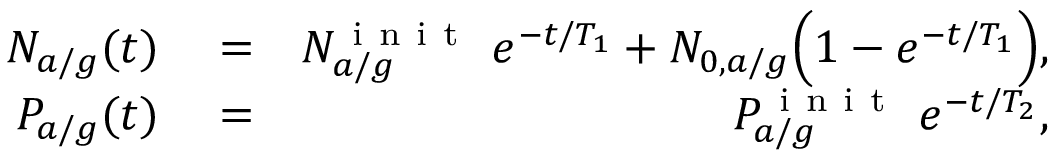Convert formula to latex. <formula><loc_0><loc_0><loc_500><loc_500>\begin{array} { r l r } { N _ { a / g } ( t ) } & = } & { N _ { a / g } ^ { i n i t } \ e ^ { - t / T _ { 1 } } + N _ { 0 , a / g } \left ( 1 - e ^ { - t / T _ { 1 } } \right ) , } \\ { P _ { a / g } ( t ) } & = } & { P _ { a / g } ^ { i n i t } \ e ^ { - t / T _ { 2 } } , } \end{array}</formula> 